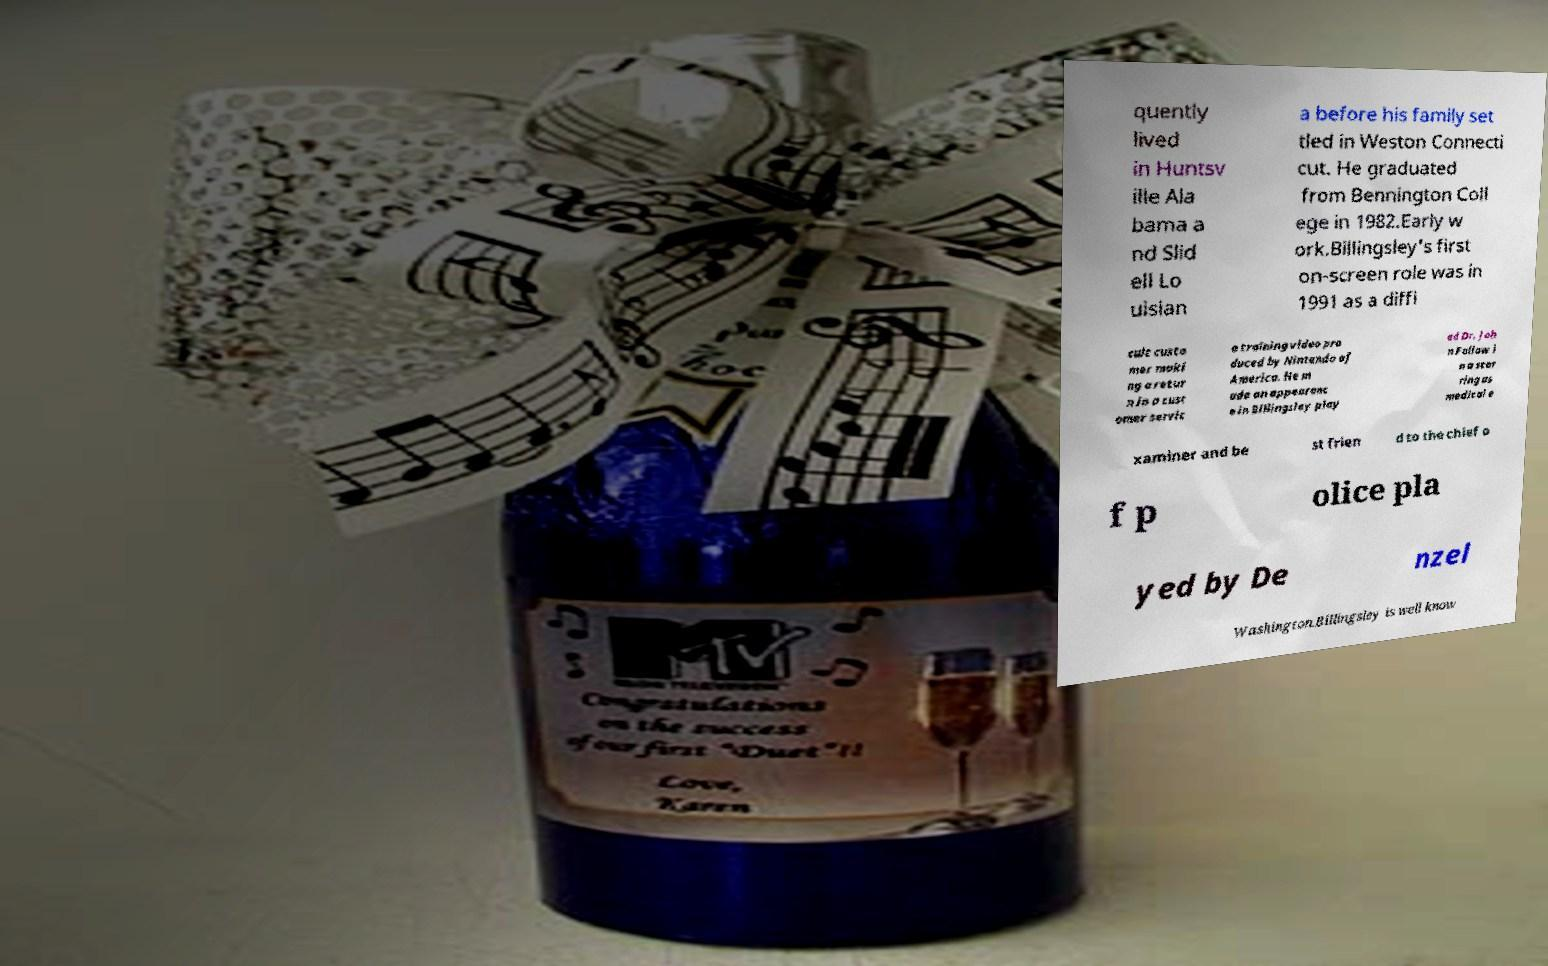Could you extract and type out the text from this image? quently lived in Huntsv ille Ala bama a nd Slid ell Lo uisian a before his family set tled in Weston Connecti cut. He graduated from Bennington Coll ege in 1982.Early w ork.Billingsley's first on-screen role was in 1991 as a diffi cult custo mer maki ng a retur n in a cust omer servic e training video pro duced by Nintendo of America. He m ade an appearanc e in Billingsley play ed Dr. Joh n Fallow i n a star ring as medical e xaminer and be st frien d to the chief o f p olice pla yed by De nzel Washington.Billingsley is well know 